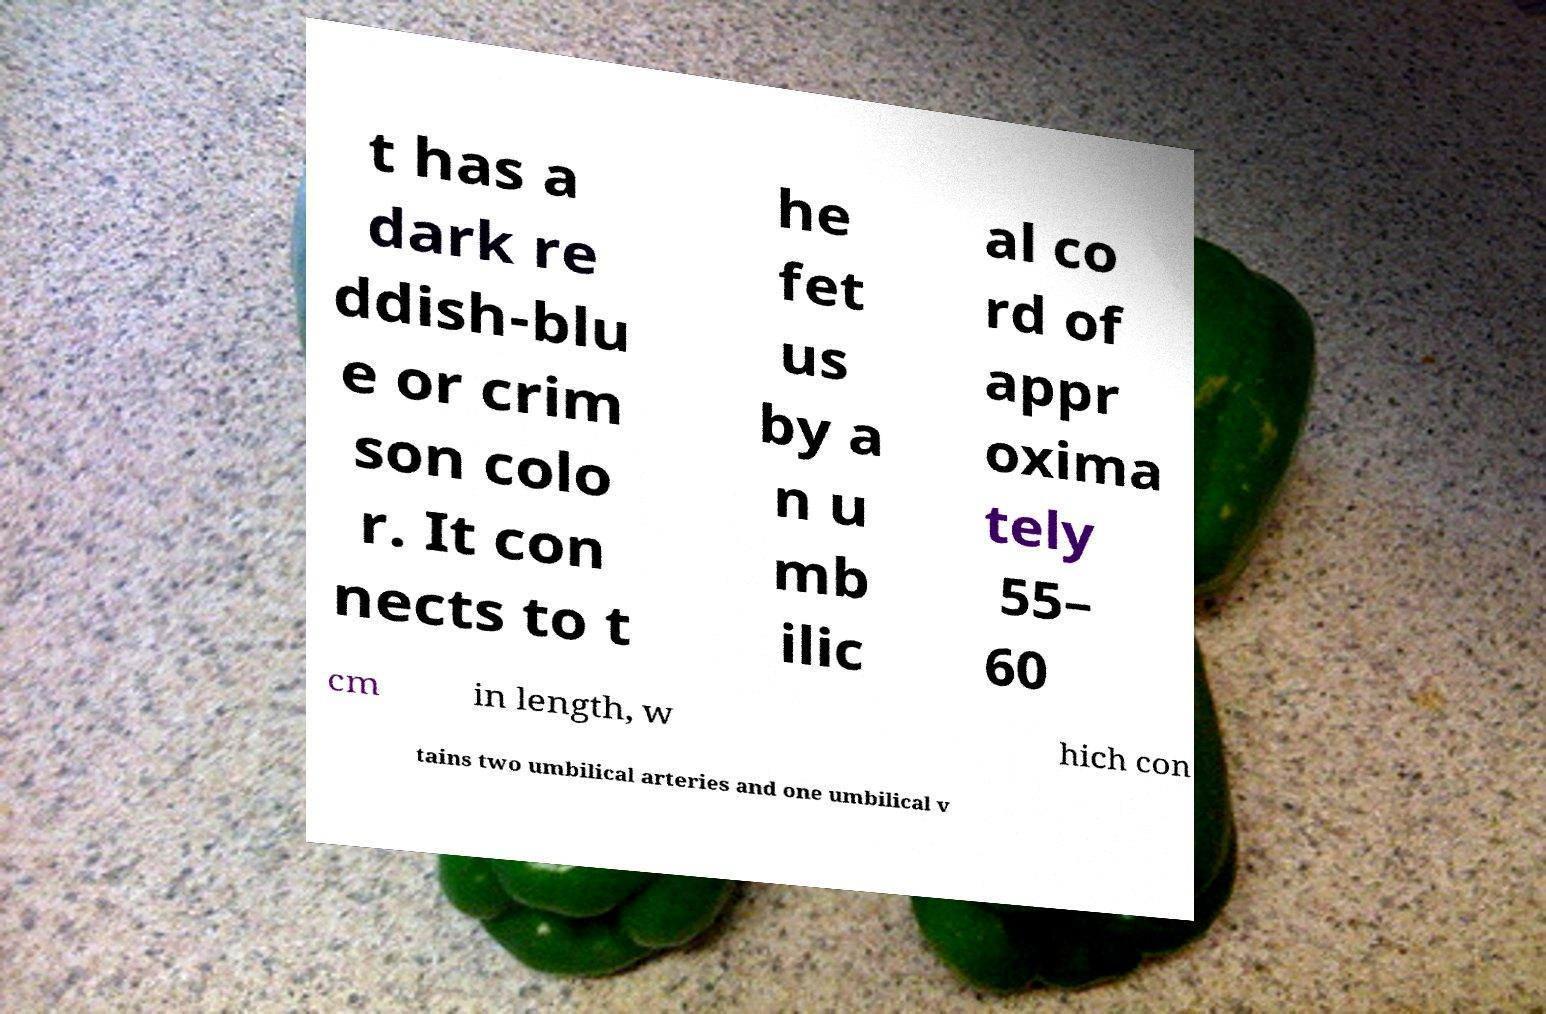Can you read and provide the text displayed in the image?This photo seems to have some interesting text. Can you extract and type it out for me? t has a dark re ddish-blu e or crim son colo r. It con nects to t he fet us by a n u mb ilic al co rd of appr oxima tely 55– 60 cm in length, w hich con tains two umbilical arteries and one umbilical v 